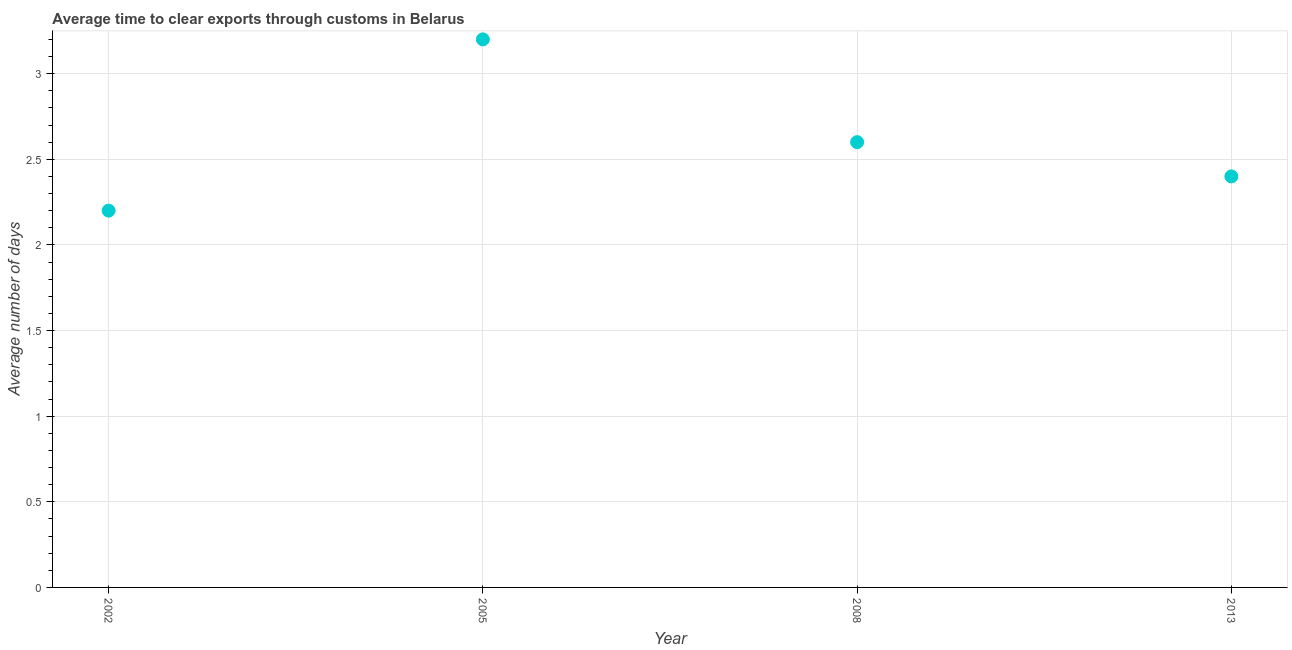Across all years, what is the maximum time to clear exports through customs?
Offer a very short reply. 3.2. Across all years, what is the minimum time to clear exports through customs?
Offer a terse response. 2.2. In which year was the time to clear exports through customs minimum?
Make the answer very short. 2002. What is the difference between the time to clear exports through customs in 2002 and 2005?
Your answer should be very brief. -1. What is the ratio of the time to clear exports through customs in 2002 to that in 2008?
Make the answer very short. 0.85. What is the difference between the highest and the second highest time to clear exports through customs?
Give a very brief answer. 0.6. Is the sum of the time to clear exports through customs in 2008 and 2013 greater than the maximum time to clear exports through customs across all years?
Your response must be concise. Yes. What is the difference between the highest and the lowest time to clear exports through customs?
Offer a terse response. 1. Are the values on the major ticks of Y-axis written in scientific E-notation?
Ensure brevity in your answer.  No. Does the graph contain any zero values?
Make the answer very short. No. Does the graph contain grids?
Ensure brevity in your answer.  Yes. What is the title of the graph?
Keep it short and to the point. Average time to clear exports through customs in Belarus. What is the label or title of the X-axis?
Offer a very short reply. Year. What is the label or title of the Y-axis?
Provide a succinct answer. Average number of days. What is the difference between the Average number of days in 2002 and 2005?
Make the answer very short. -1. What is the difference between the Average number of days in 2002 and 2008?
Offer a very short reply. -0.4. What is the difference between the Average number of days in 2002 and 2013?
Give a very brief answer. -0.2. What is the difference between the Average number of days in 2005 and 2008?
Provide a short and direct response. 0.6. What is the ratio of the Average number of days in 2002 to that in 2005?
Keep it short and to the point. 0.69. What is the ratio of the Average number of days in 2002 to that in 2008?
Make the answer very short. 0.85. What is the ratio of the Average number of days in 2002 to that in 2013?
Provide a short and direct response. 0.92. What is the ratio of the Average number of days in 2005 to that in 2008?
Keep it short and to the point. 1.23. What is the ratio of the Average number of days in 2005 to that in 2013?
Ensure brevity in your answer.  1.33. What is the ratio of the Average number of days in 2008 to that in 2013?
Provide a succinct answer. 1.08. 